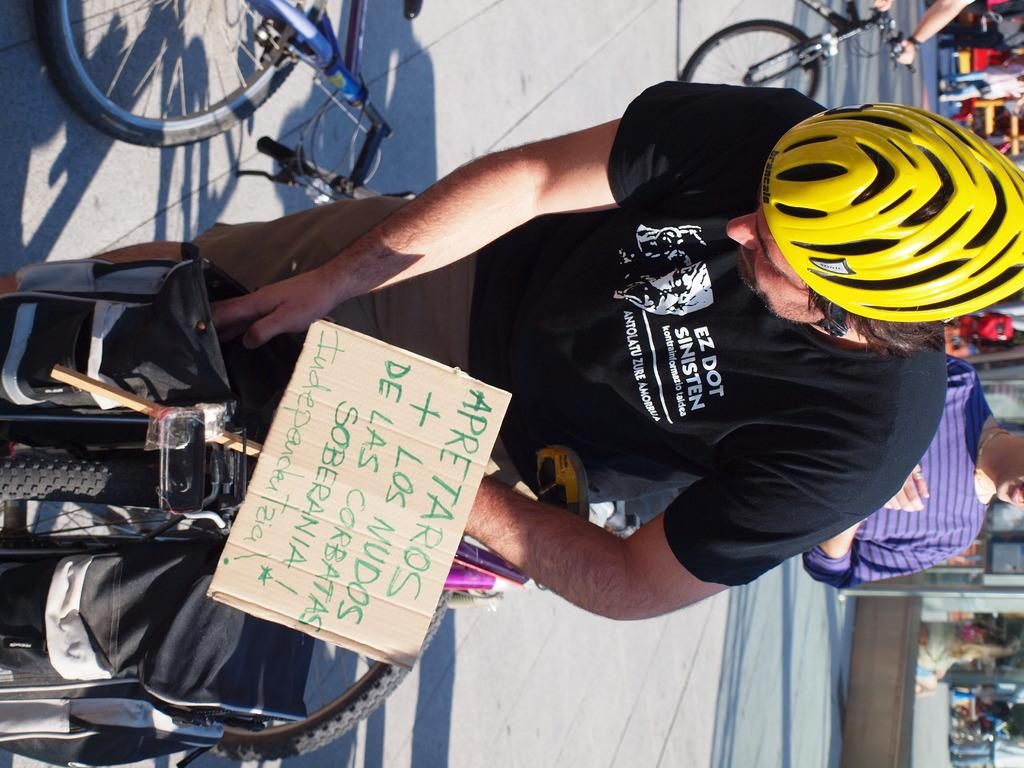<image>
Render a clear and concise summary of the photo. Person wearing a black shirt which says "EZ Dot" on it. 